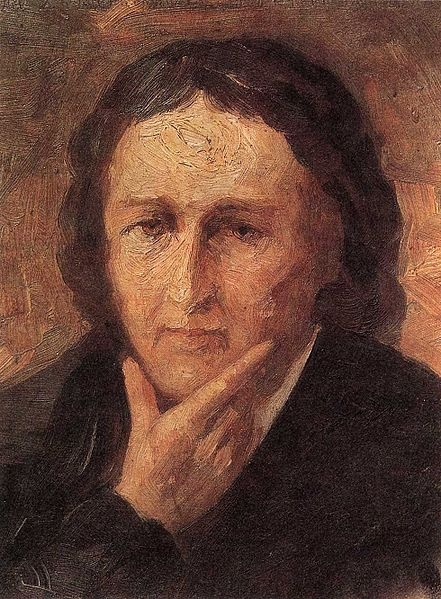What is this photo about? The image portrays a solemn individual with long, dark hair, resting their chin on their hand, immersed in thought. The vibrant background painted with lively, warm hues contrasts sharply with the person's calm, introspective demeanor. The artwork is reminiscent of the post-impressionist style, characterized by its focus on evoking emotional responses through vivid colors and visible, dynamic brushstrokes. This painting not only captures the physical attributes of the individual but also conveys a deeper glimpse into their emotional state, possibly reflecting moments of introspection or melancholy. 